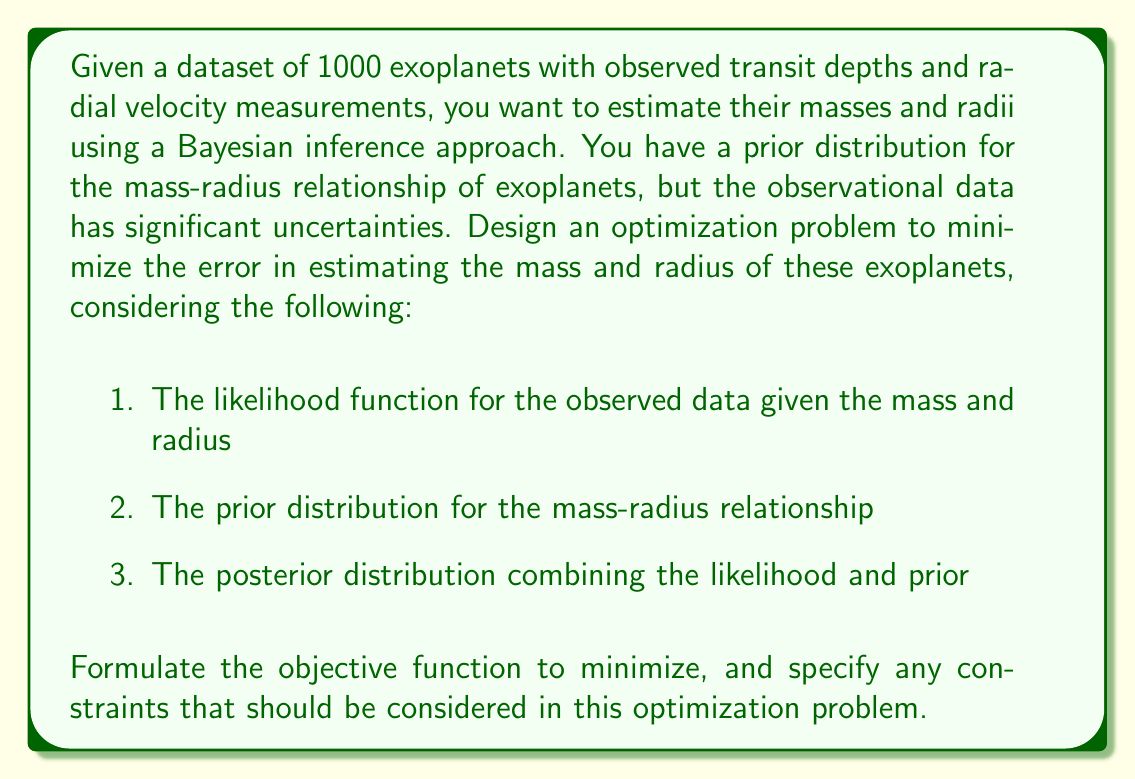Help me with this question. To minimize the error in estimating exoplanet mass and radius using limited observational data, we can formulate a Bayesian inference optimization problem. The goal is to maximize the posterior probability of the mass and radius estimates given the observed data.

1. Likelihood function:
Let $D$ represent the observed data (transit depths and radial velocity measurements), $M$ the mass, and $R$ the radius of an exoplanet. The likelihood function can be expressed as:

$$P(D|M,R) = \prod_{i=1}^{N} P(d_i|M,R)$$

where $N$ is the number of observations, and $d_i$ represents individual data points.

2. Prior distribution:
The mass-radius relationship can be modeled using a power law:

$$R = \alpha M^\beta$$

where $\alpha$ and $\beta$ are parameters with their own prior distributions. The prior for mass and radius can be expressed as:

$$P(M,R) = P(R|M)P(M)$$

3. Posterior distribution:
Using Bayes' theorem, we can combine the likelihood and prior to obtain the posterior distribution:

$$P(M,R|D) \propto P(D|M,R)P(M,R)$$

Objective function:
To minimize the error in estimating mass and radius, we want to maximize the posterior probability. This is equivalent to minimizing the negative log posterior:

$$\min_{M,R} -\log P(M,R|D) = -\log P(D|M,R) - \log P(M,R) + \text{constant}$$

Constraints:
1. Mass and radius must be positive: $M > 0$, $R > 0$
2. Physical constraints based on known exoplanet properties: $0.1M_{\text{Earth}} \leq M \leq 100M_{\text{Jupiter}}$, $0.1R_{\text{Earth}} \leq R \leq 5R_{\text{Jupiter}}$

The optimization problem can be solved using numerical methods such as Markov Chain Monte Carlo (MCMC) or gradient-based optimization techniques, depending on the specific forms of the likelihood and prior distributions.
Answer: The optimization problem to minimize error in estimating exoplanet mass and radius is:

$$\min_{M,R} -\log P(D|M,R) - \log P(M,R)$$

subject to:
$$M > 0, R > 0$$
$$0.1M_{\text{Earth}} \leq M \leq 100M_{\text{Jupiter}}$$
$$0.1R_{\text{Earth}} \leq R \leq 5R_{\text{Jupiter}}$$ 